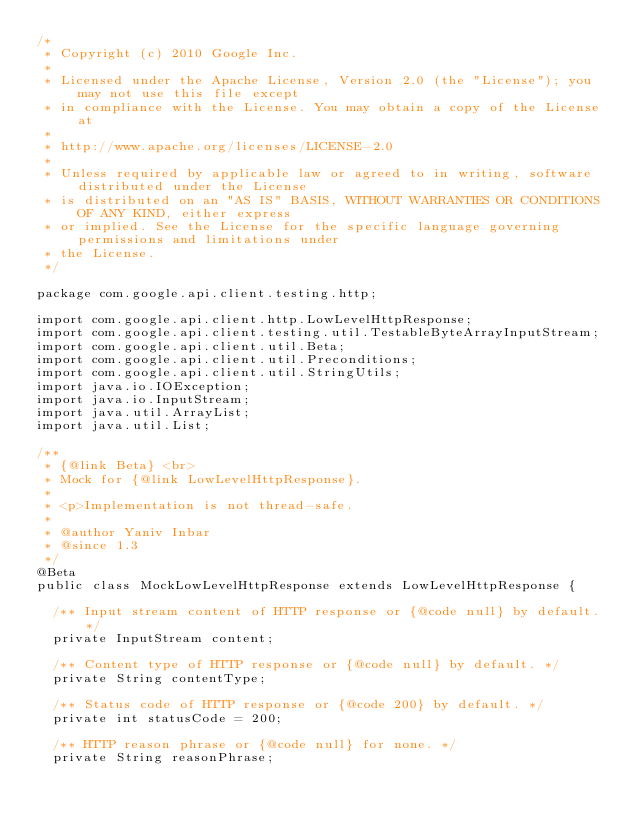<code> <loc_0><loc_0><loc_500><loc_500><_Java_>/*
 * Copyright (c) 2010 Google Inc.
 *
 * Licensed under the Apache License, Version 2.0 (the "License"); you may not use this file except
 * in compliance with the License. You may obtain a copy of the License at
 *
 * http://www.apache.org/licenses/LICENSE-2.0
 *
 * Unless required by applicable law or agreed to in writing, software distributed under the License
 * is distributed on an "AS IS" BASIS, WITHOUT WARRANTIES OR CONDITIONS OF ANY KIND, either express
 * or implied. See the License for the specific language governing permissions and limitations under
 * the License.
 */

package com.google.api.client.testing.http;

import com.google.api.client.http.LowLevelHttpResponse;
import com.google.api.client.testing.util.TestableByteArrayInputStream;
import com.google.api.client.util.Beta;
import com.google.api.client.util.Preconditions;
import com.google.api.client.util.StringUtils;
import java.io.IOException;
import java.io.InputStream;
import java.util.ArrayList;
import java.util.List;

/**
 * {@link Beta} <br>
 * Mock for {@link LowLevelHttpResponse}.
 *
 * <p>Implementation is not thread-safe.
 *
 * @author Yaniv Inbar
 * @since 1.3
 */
@Beta
public class MockLowLevelHttpResponse extends LowLevelHttpResponse {

  /** Input stream content of HTTP response or {@code null} by default. */
  private InputStream content;

  /** Content type of HTTP response or {@code null} by default. */
  private String contentType;

  /** Status code of HTTP response or {@code 200} by default. */
  private int statusCode = 200;

  /** HTTP reason phrase or {@code null} for none. */
  private String reasonPhrase;
</code> 